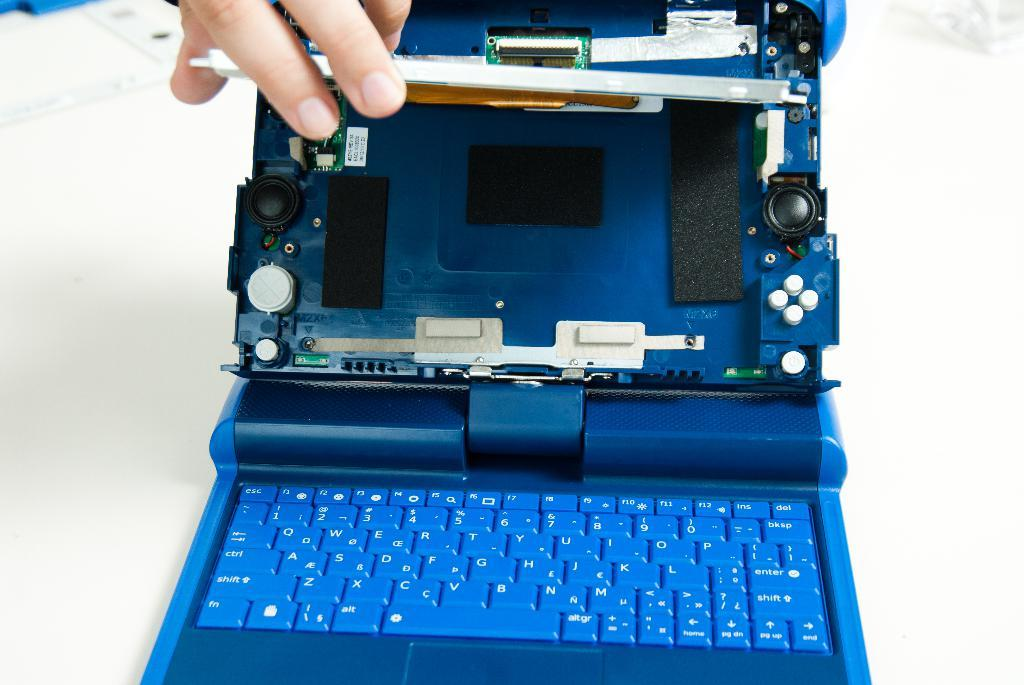<image>
Offer a succinct explanation of the picture presented. Blue laptop with the screen removed and a tiny sticker inside that says "3ZYE REV 34". 